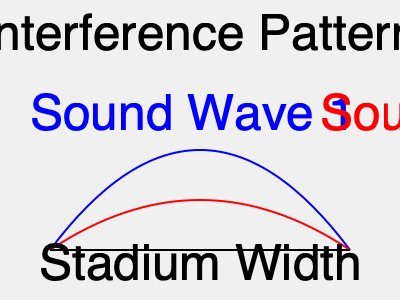In a football stadium, two identical speakers are placed at opposite ends, emitting sound waves with a frequency of 680 Hz. If the speed of sound in the stadium is 340 m/s and constructive interference occurs at the midpoint between the speakers, what is the minimum width of the stadium? To solve this problem, we'll follow these steps:

1. Understand the concept of constructive interference:
   Constructive interference occurs when the path difference between two waves is an integer multiple of the wavelength.

2. Calculate the wavelength of the sound:
   $\lambda = \frac{v}{f}$, where $v$ is the speed of sound and $f$ is the frequency.
   $\lambda = \frac{340 \text{ m/s}}{680 \text{ Hz}} = 0.5 \text{ m}$

3. For constructive interference at the midpoint, the path difference must be a whole number of wavelengths:
   $n\lambda = d_1 - d_2$, where $n$ is an integer, and $d_1$ and $d_2$ are the distances from each speaker to the midpoint.

4. In this case, $d_1 = d_2 = \frac{w}{2}$, where $w$ is the width of the stadium.
   The path difference is $w - \frac{w}{2} = \frac{w}{2}$

5. Therefore, $n\lambda = \frac{w}{2}$

6. The minimum width occurs when $n = 1$:
   $0.5 \text{ m} = \frac{w}{2}$

7. Solve for $w$:
   $w = 2 \times 0.5 \text{ m} = 1 \text{ m}$

Thus, the minimum width of the stadium for constructive interference to occur at the midpoint is 1 meter.
Answer: 1 meter 